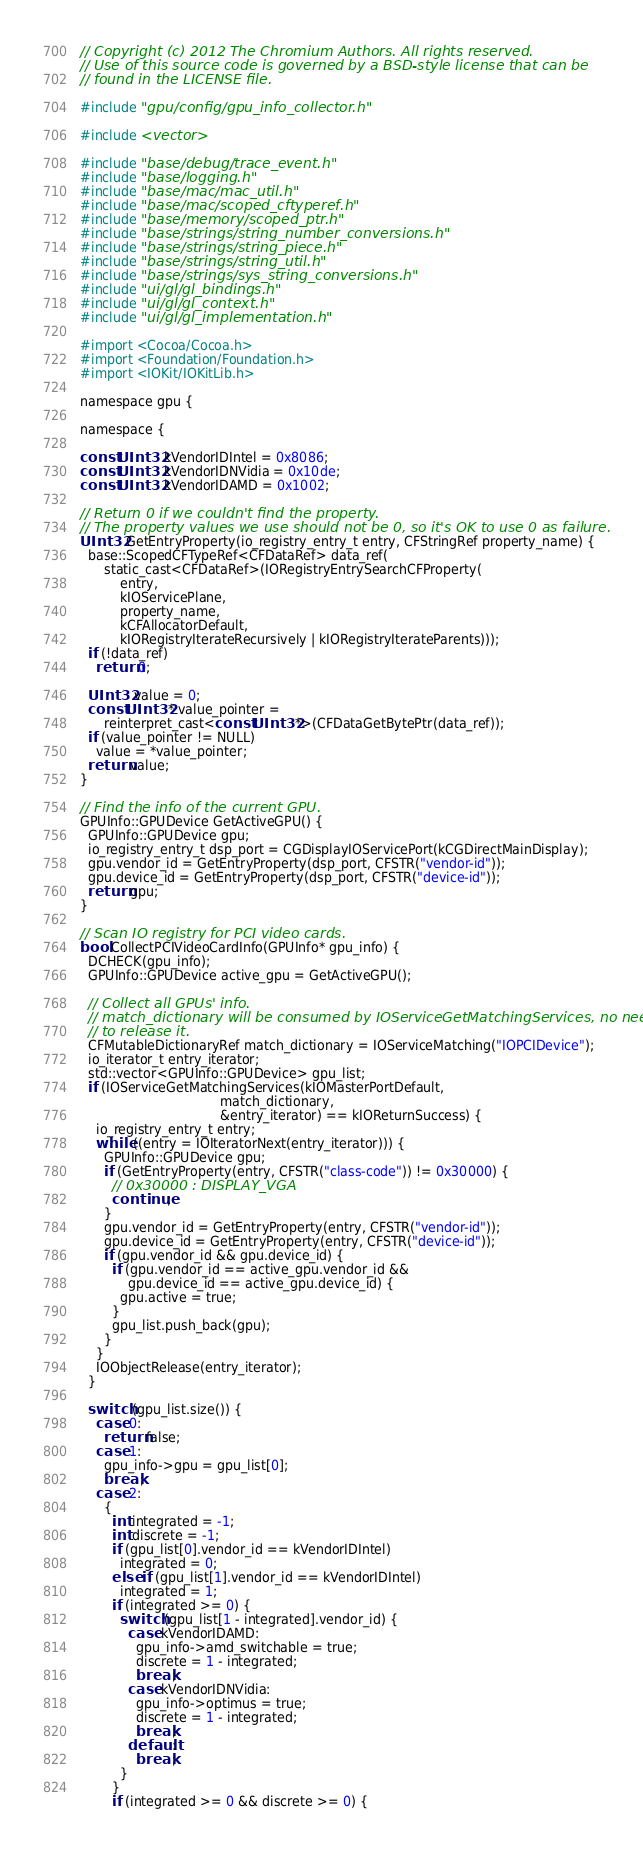<code> <loc_0><loc_0><loc_500><loc_500><_ObjectiveC_>// Copyright (c) 2012 The Chromium Authors. All rights reserved.
// Use of this source code is governed by a BSD-style license that can be
// found in the LICENSE file.

#include "gpu/config/gpu_info_collector.h"

#include <vector>

#include "base/debug/trace_event.h"
#include "base/logging.h"
#include "base/mac/mac_util.h"
#include "base/mac/scoped_cftyperef.h"
#include "base/memory/scoped_ptr.h"
#include "base/strings/string_number_conversions.h"
#include "base/strings/string_piece.h"
#include "base/strings/string_util.h"
#include "base/strings/sys_string_conversions.h"
#include "ui/gl/gl_bindings.h"
#include "ui/gl/gl_context.h"
#include "ui/gl/gl_implementation.h"

#import <Cocoa/Cocoa.h>
#import <Foundation/Foundation.h>
#import <IOKit/IOKitLib.h>

namespace gpu {

namespace {

const UInt32 kVendorIDIntel = 0x8086;
const UInt32 kVendorIDNVidia = 0x10de;
const UInt32 kVendorIDAMD = 0x1002;

// Return 0 if we couldn't find the property.
// The property values we use should not be 0, so it's OK to use 0 as failure.
UInt32 GetEntryProperty(io_registry_entry_t entry, CFStringRef property_name) {
  base::ScopedCFTypeRef<CFDataRef> data_ref(
      static_cast<CFDataRef>(IORegistryEntrySearchCFProperty(
          entry,
          kIOServicePlane,
          property_name,
          kCFAllocatorDefault,
          kIORegistryIterateRecursively | kIORegistryIterateParents)));
  if (!data_ref)
    return 0;

  UInt32 value = 0;
  const UInt32* value_pointer =
      reinterpret_cast<const UInt32*>(CFDataGetBytePtr(data_ref));
  if (value_pointer != NULL)
    value = *value_pointer;
  return value;
}

// Find the info of the current GPU.
GPUInfo::GPUDevice GetActiveGPU() {
  GPUInfo::GPUDevice gpu;
  io_registry_entry_t dsp_port = CGDisplayIOServicePort(kCGDirectMainDisplay);
  gpu.vendor_id = GetEntryProperty(dsp_port, CFSTR("vendor-id"));
  gpu.device_id = GetEntryProperty(dsp_port, CFSTR("device-id"));
  return gpu;
}

// Scan IO registry for PCI video cards.
bool CollectPCIVideoCardInfo(GPUInfo* gpu_info) {
  DCHECK(gpu_info);
  GPUInfo::GPUDevice active_gpu = GetActiveGPU();

  // Collect all GPUs' info.
  // match_dictionary will be consumed by IOServiceGetMatchingServices, no need
  // to release it.
  CFMutableDictionaryRef match_dictionary = IOServiceMatching("IOPCIDevice");
  io_iterator_t entry_iterator;
  std::vector<GPUInfo::GPUDevice> gpu_list;
  if (IOServiceGetMatchingServices(kIOMasterPortDefault,
                                   match_dictionary,
                                   &entry_iterator) == kIOReturnSuccess) {
    io_registry_entry_t entry;
    while ((entry = IOIteratorNext(entry_iterator))) {
      GPUInfo::GPUDevice gpu;
      if (GetEntryProperty(entry, CFSTR("class-code")) != 0x30000) {
        // 0x30000 : DISPLAY_VGA
        continue;
      }
      gpu.vendor_id = GetEntryProperty(entry, CFSTR("vendor-id"));
      gpu.device_id = GetEntryProperty(entry, CFSTR("device-id"));
      if (gpu.vendor_id && gpu.device_id) {
        if (gpu.vendor_id == active_gpu.vendor_id &&
            gpu.device_id == active_gpu.device_id) {
          gpu.active = true;
        }
        gpu_list.push_back(gpu);
      }
    }
    IOObjectRelease(entry_iterator);
  }

  switch (gpu_list.size()) {
    case 0:
      return false;
    case 1:
      gpu_info->gpu = gpu_list[0];
      break;
    case 2:
      {
        int integrated = -1;
        int discrete = -1;
        if (gpu_list[0].vendor_id == kVendorIDIntel)
          integrated = 0;
        else if (gpu_list[1].vendor_id == kVendorIDIntel)
          integrated = 1;
        if (integrated >= 0) {
          switch (gpu_list[1 - integrated].vendor_id) {
            case kVendorIDAMD:
              gpu_info->amd_switchable = true;
              discrete = 1 - integrated;
              break;
            case kVendorIDNVidia:
              gpu_info->optimus = true;
              discrete = 1 - integrated;
              break;
            default:
              break;
          }
        }
        if (integrated >= 0 && discrete >= 0) {</code> 